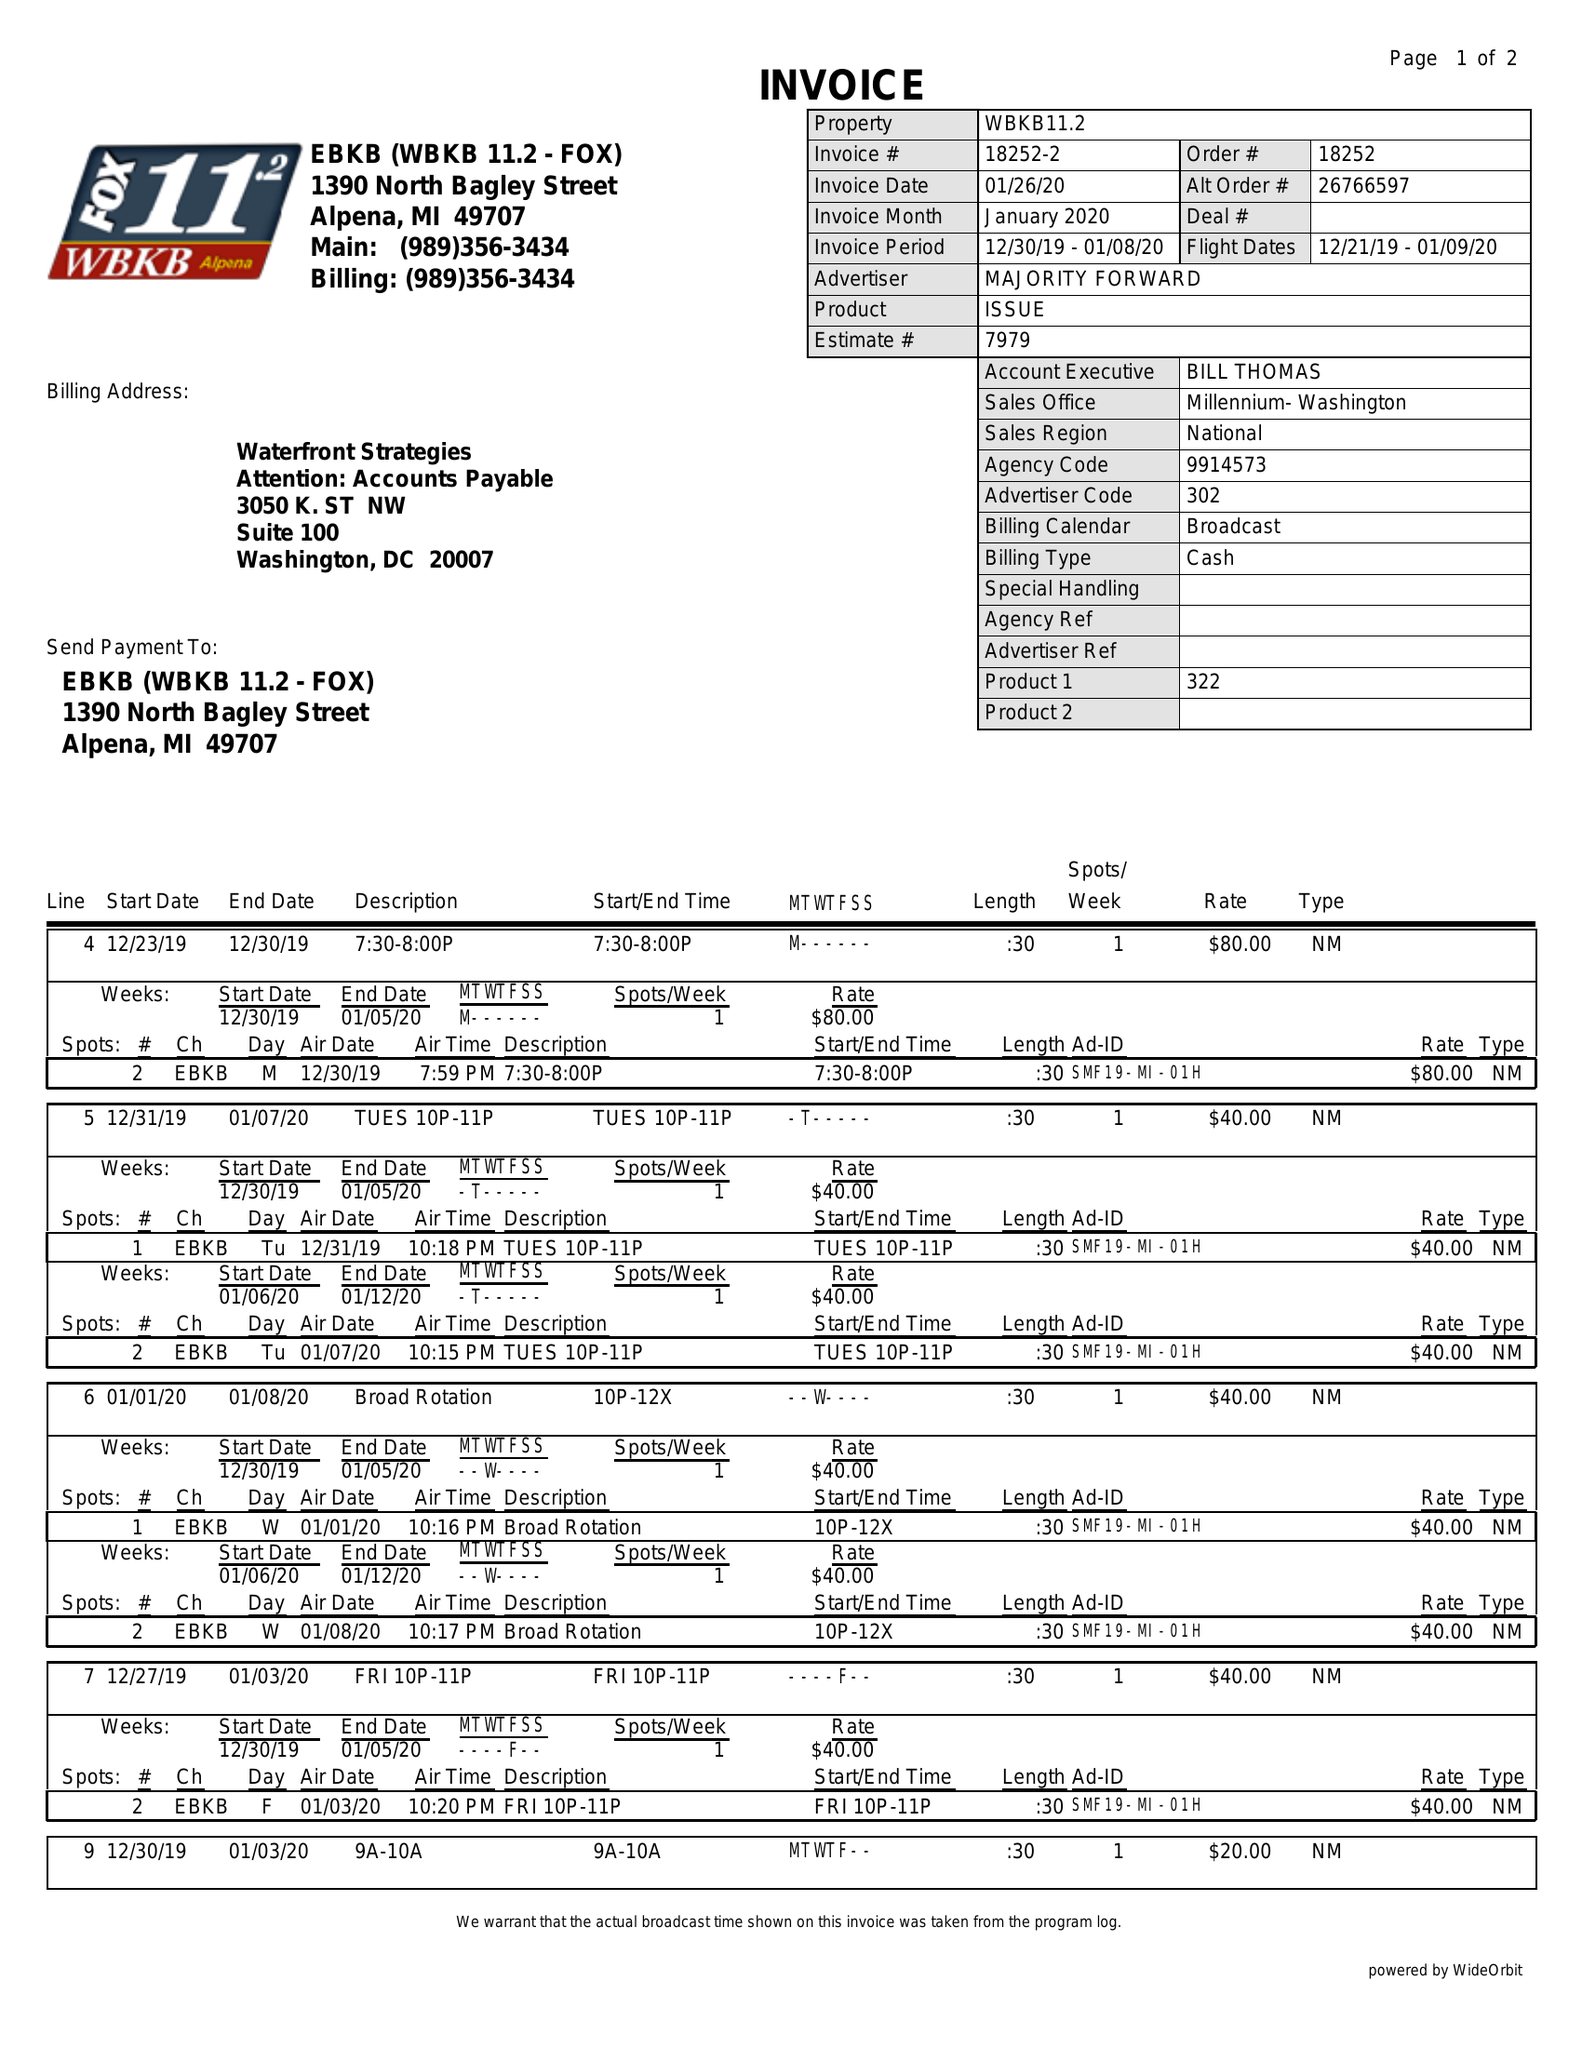What is the value for the flight_from?
Answer the question using a single word or phrase. 12/21/19 